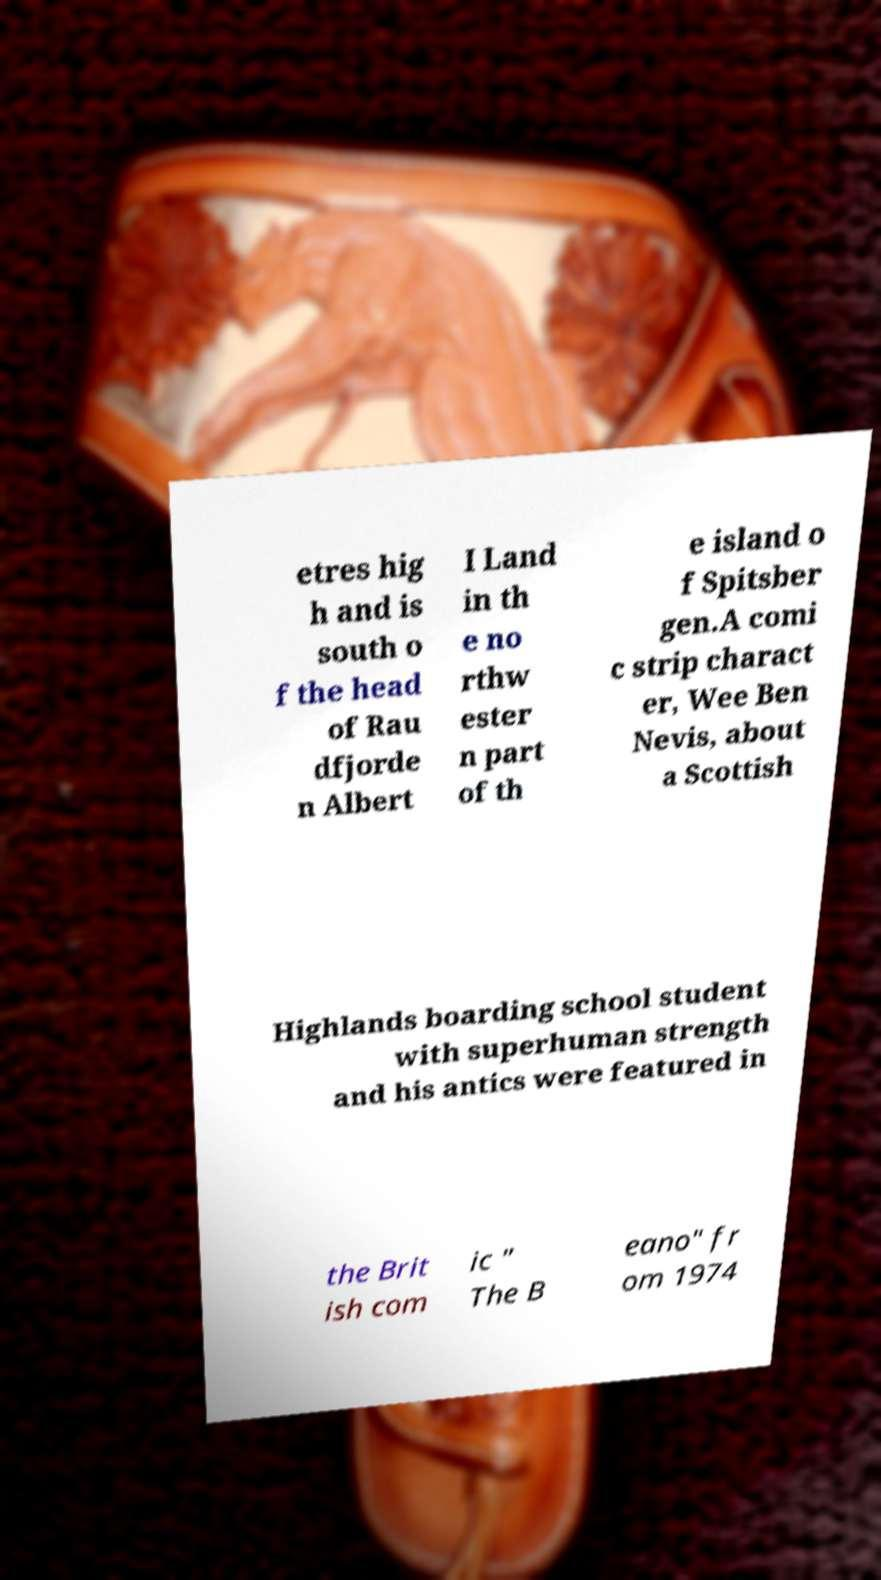Can you accurately transcribe the text from the provided image for me? etres hig h and is south o f the head of Rau dfjorde n Albert I Land in th e no rthw ester n part of th e island o f Spitsber gen.A comi c strip charact er, Wee Ben Nevis, about a Scottish Highlands boarding school student with superhuman strength and his antics were featured in the Brit ish com ic " The B eano" fr om 1974 